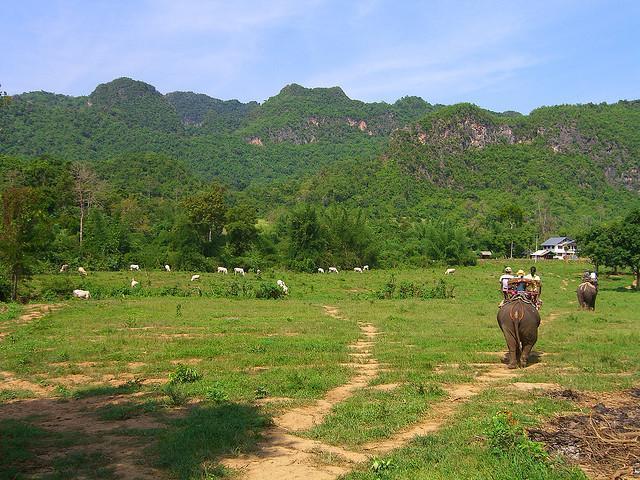How many elephants are there?
Give a very brief answer. 2. 